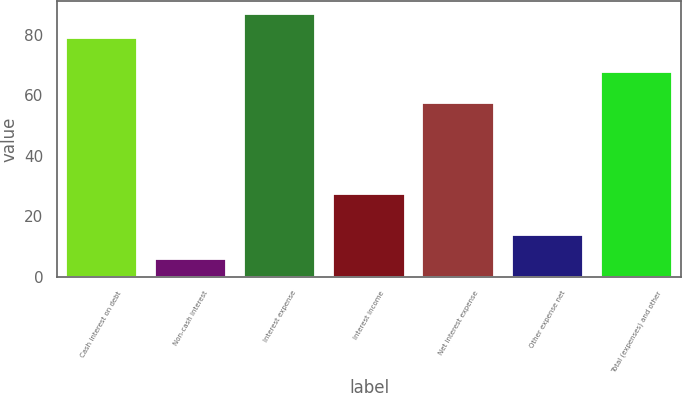Convert chart. <chart><loc_0><loc_0><loc_500><loc_500><bar_chart><fcel>Cash interest on debt<fcel>Non-cash interest<fcel>Interest expense<fcel>Interest income<fcel>Net interest expense<fcel>Other expense net<fcel>Total (expenses) and other<nl><fcel>78.9<fcel>6<fcel>86.79<fcel>27.4<fcel>57.5<fcel>13.89<fcel>67.7<nl></chart> 